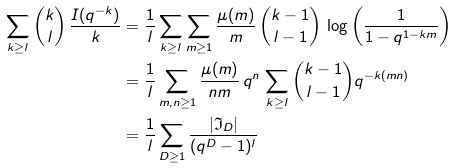Convert formula to latex. <formula><loc_0><loc_0><loc_500><loc_500>\sum _ { k \geq l } \binom { k } { l } \, \frac { I ( q ^ { - k } ) } { k } & = \frac { 1 } { l } \sum _ { k \geq l } \sum _ { m \geq 1 } \frac { \mu ( m ) } { m } \, \binom { k - 1 } { l - 1 } \, \log \left ( \frac { 1 } { 1 - q ^ { 1 - k m } } \right ) \\ & = \frac { 1 } { l } \sum _ { m , n \geq 1 } \frac { \mu ( m ) } { n m } \, q ^ { n } \, \sum _ { k \geq l } \binom { k - 1 } { l - 1 } q ^ { - k ( m n ) } \\ & = \frac { 1 } { l } \sum _ { D \geq 1 } \frac { | \mathfrak { I } _ { D } | } { ( q ^ { D } - 1 ) ^ { l } }</formula> 